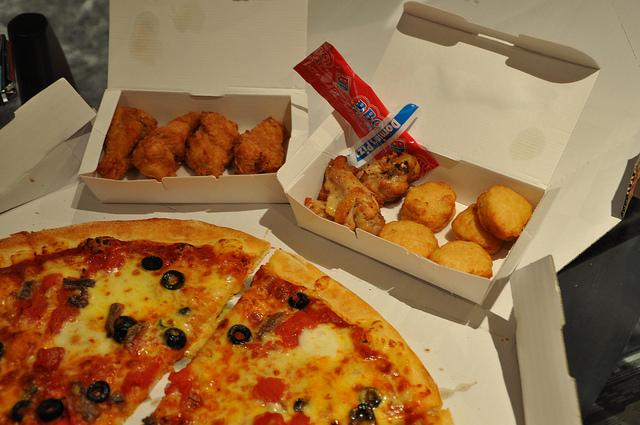Is this pizza homemade?
Short answer required. No. What foods are in this picture?
Keep it brief. Pizza and nuggets. Why is the condiment packet taped to the box?
Answer briefly. Catch up. 